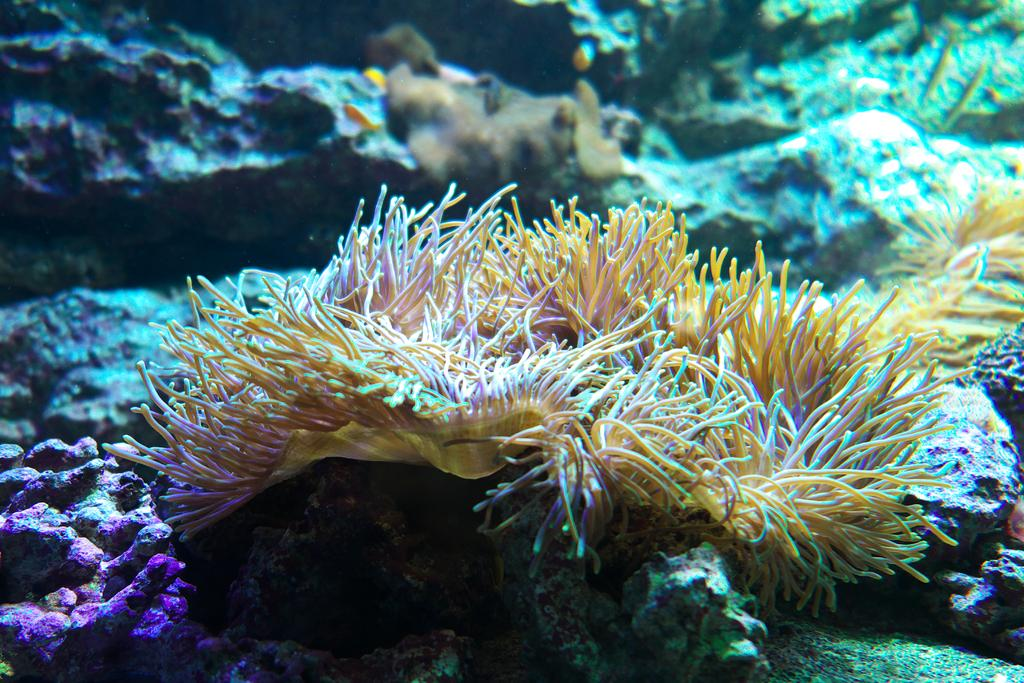What type of natural formation can be seen on the path in the image? There are corals on the path in the image. What other geological features are visible in the image? There are rocks visible behind the corals in the image. Can you describe what is behind the corals and rocks in the image? There are other unspecified things visible behind the corals in the image. What type of health services are available at the airport in the image? There is no airport present in the image, and therefore no health services can be discussed. 